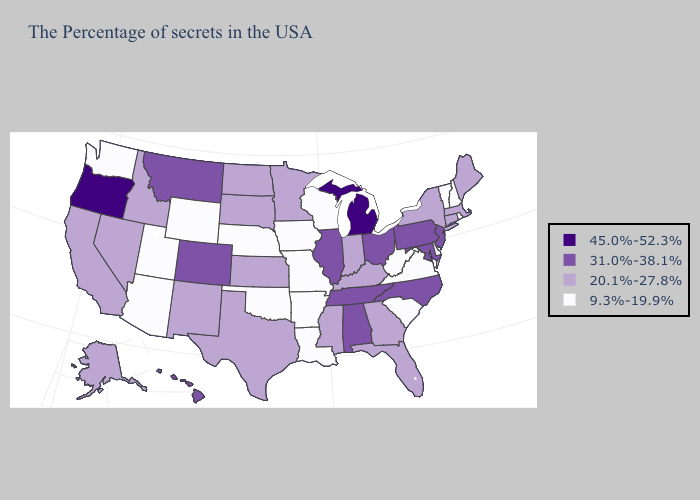What is the value of Washington?
Give a very brief answer. 9.3%-19.9%. What is the value of Oregon?
Short answer required. 45.0%-52.3%. Among the states that border Nevada , does California have the lowest value?
Answer briefly. No. Name the states that have a value in the range 45.0%-52.3%?
Be succinct. Michigan, Oregon. Does Oklahoma have a lower value than Indiana?
Give a very brief answer. Yes. Which states hav the highest value in the West?
Be succinct. Oregon. Name the states that have a value in the range 31.0%-38.1%?
Answer briefly. New Jersey, Maryland, Pennsylvania, North Carolina, Ohio, Alabama, Tennessee, Illinois, Colorado, Montana, Hawaii. Among the states that border Kentucky , does Indiana have the lowest value?
Be succinct. No. Among the states that border Indiana , does Kentucky have the lowest value?
Keep it brief. Yes. Which states hav the highest value in the South?
Be succinct. Maryland, North Carolina, Alabama, Tennessee. What is the value of Georgia?
Write a very short answer. 20.1%-27.8%. Does New York have a higher value than Kansas?
Quick response, please. No. Does Michigan have the highest value in the USA?
Write a very short answer. Yes. What is the value of Delaware?
Answer briefly. 9.3%-19.9%. What is the value of Georgia?
Answer briefly. 20.1%-27.8%. 